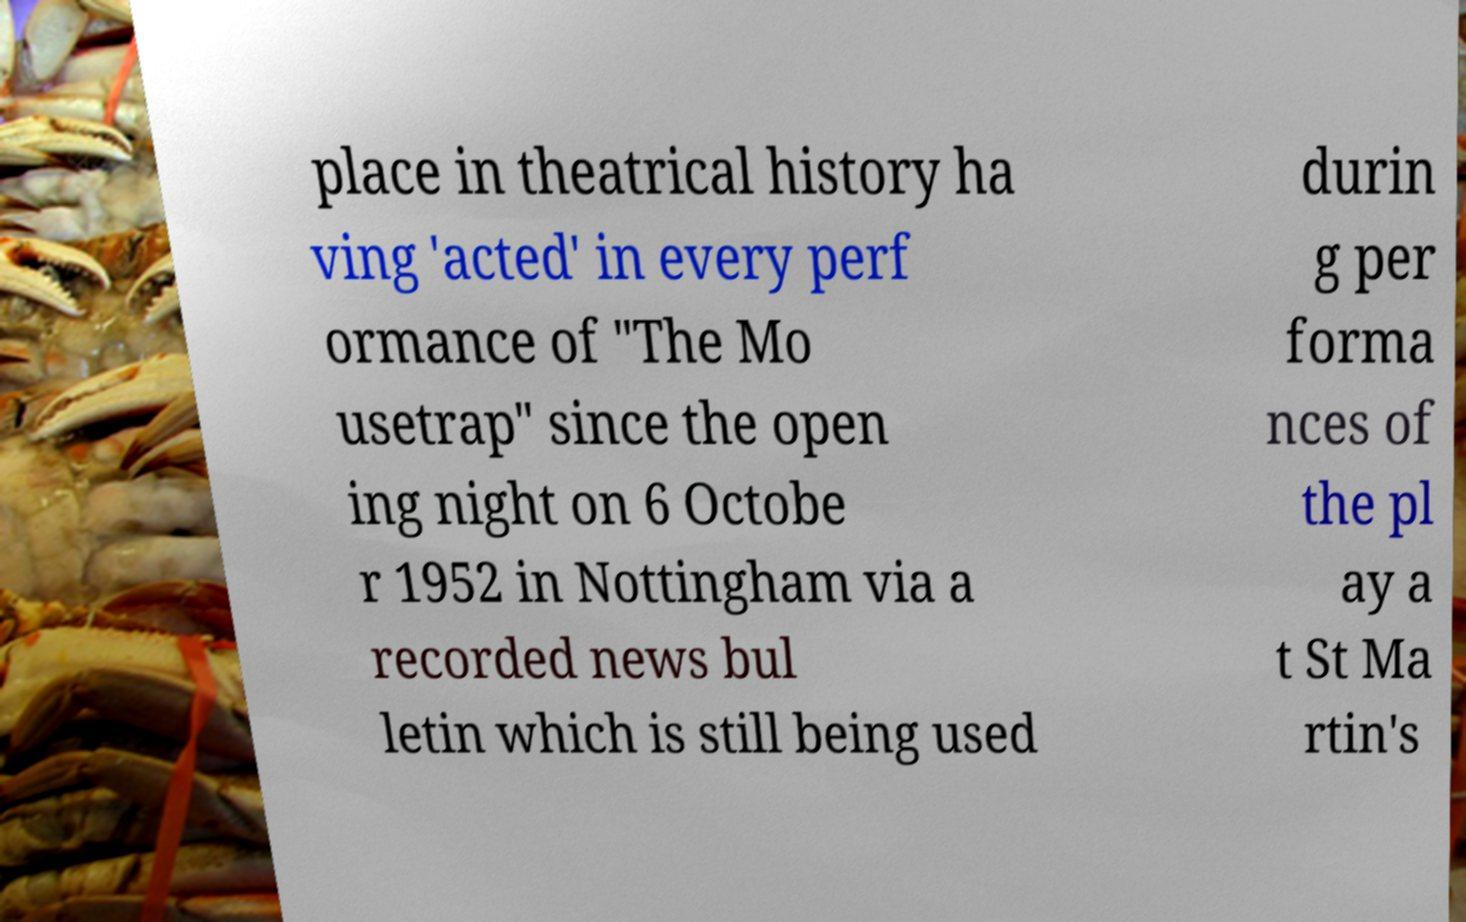Please read and relay the text visible in this image. What does it say? place in theatrical history ha ving 'acted' in every perf ormance of "The Mo usetrap" since the open ing night on 6 Octobe r 1952 in Nottingham via a recorded news bul letin which is still being used durin g per forma nces of the pl ay a t St Ma rtin's 